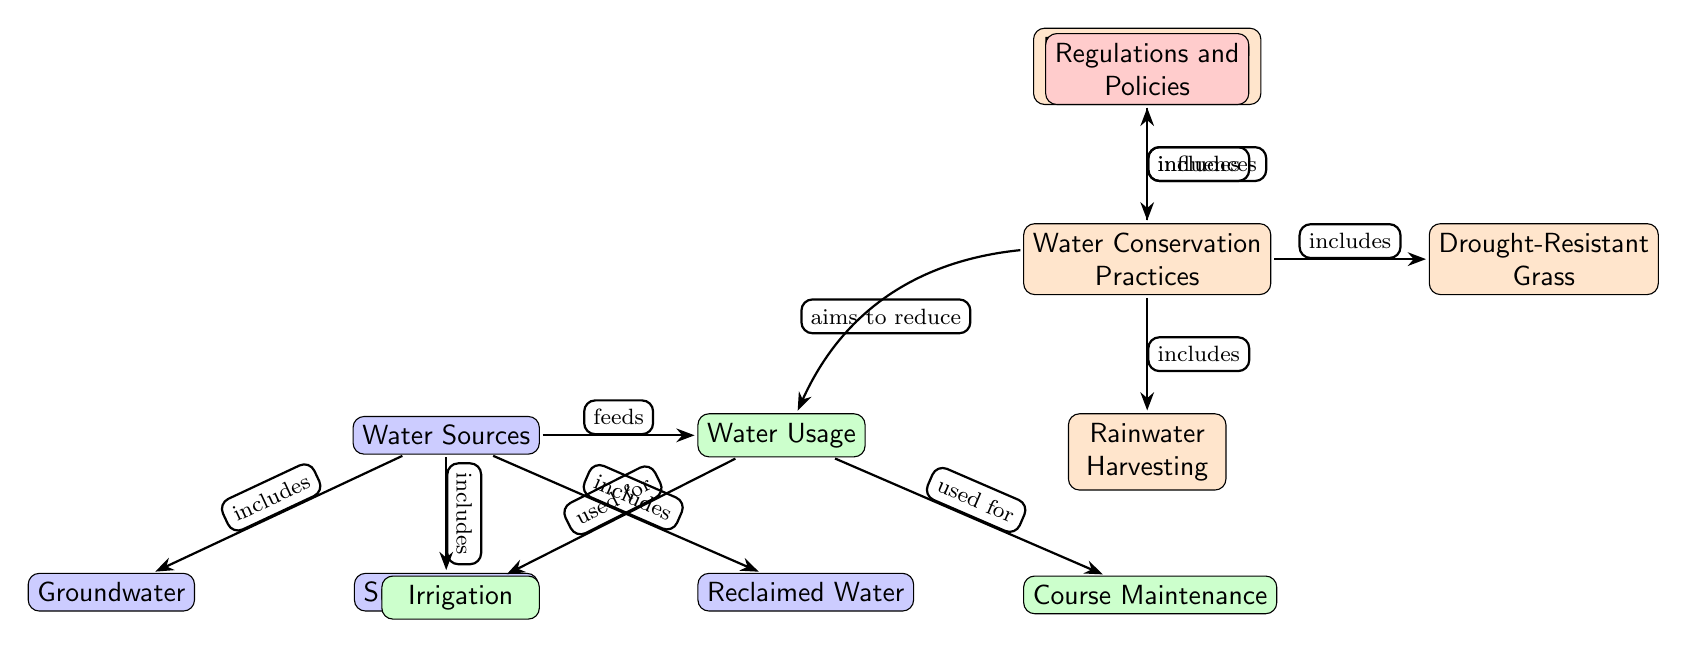What are the three main water sources listed in the diagram? The diagram explicitly lists three water sources: Groundwater, Surface Water, and Reclaimed Water. This can be identified from the nodes labeled under "Water Sources."
Answer: Groundwater, Surface Water, Reclaimed Water How many types of water conservation practices are mentioned? The diagram lists three specific water conservation practices: Efficient Irrigation Systems, Drought-Resistant Grass, and Rainwater Harvesting. Counting these nodes gives the total.
Answer: 3 What is the connection type between "Water Sources" and "Water Usage"? The connection type shown in the diagram is labeled as "feeds," indicating that water sources are used as inputs for water usage. This relationship indicates a flow from water sources to water usage.
Answer: feeds Which water conservation practice aims to reduce water usage? "Water Conservation Practices" is a category that includes Practices aiming to reduce water, specifically noted as a connection with an arrow indicating this purpose towards "Water Usage." The practice in this category that directly relates is shown as part of the diagram's flow.
Answer: Water Conservation Practices Which node influences the water conservation practices? The arrow from the "Regulations and Policies" node points directly to "Water Conservation Practices," indicating that regulations and policies have a direct impact or influence on how water conservation is approached in golf courses.
Answer: Regulations and Policies How is surface water categorized in the diagram? Surface water is categorized as one of the main sources of water, indicated by its node under "Water Sources." This categorization explicitly mentions that it is included under the broader term of water sources.
Answer: included What are the two primary uses of water in golf courses shown in the diagram? The diagram identifies two primary uses of water in golf courses, which are labeled as Irrigation and Course Maintenance. These nodes show directly how water is utilized in the context of golf courses.
Answer: Irrigation, Course Maintenance Explain the relationship between water conservation practices and their execution. The diagram shows that various water conservation practices fall under their main category, and they aim to reduce water usage, indicating how these practices are executed to manage water efficiently. This implies a systematic approach to conservation.
Answer: aim to reduce What type of grass is mentioned as a water conservation practice? The diagram explicitly mentions "Drought-Resistant Grass" as a type of grass included under water conservation practices, linking it to specific efforts in managing water usage effectively.
Answer: Drought-Resistant Grass 